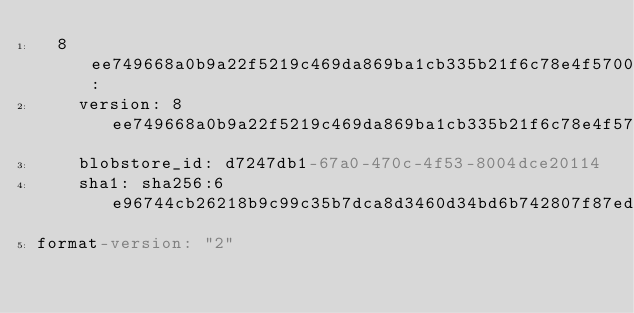<code> <loc_0><loc_0><loc_500><loc_500><_YAML_>  8ee749668a0b9a22f5219c469da869ba1cb335b21f6c78e4f5700e5f0d200620:
    version: 8ee749668a0b9a22f5219c469da869ba1cb335b21f6c78e4f5700e5f0d200620
    blobstore_id: d7247db1-67a0-470c-4f53-8004dce20114
    sha1: sha256:6e96744cb26218b9c99c35b7dca8d3460d34bd6b742807f87edc64aaee0f30ee
format-version: "2"
</code> 